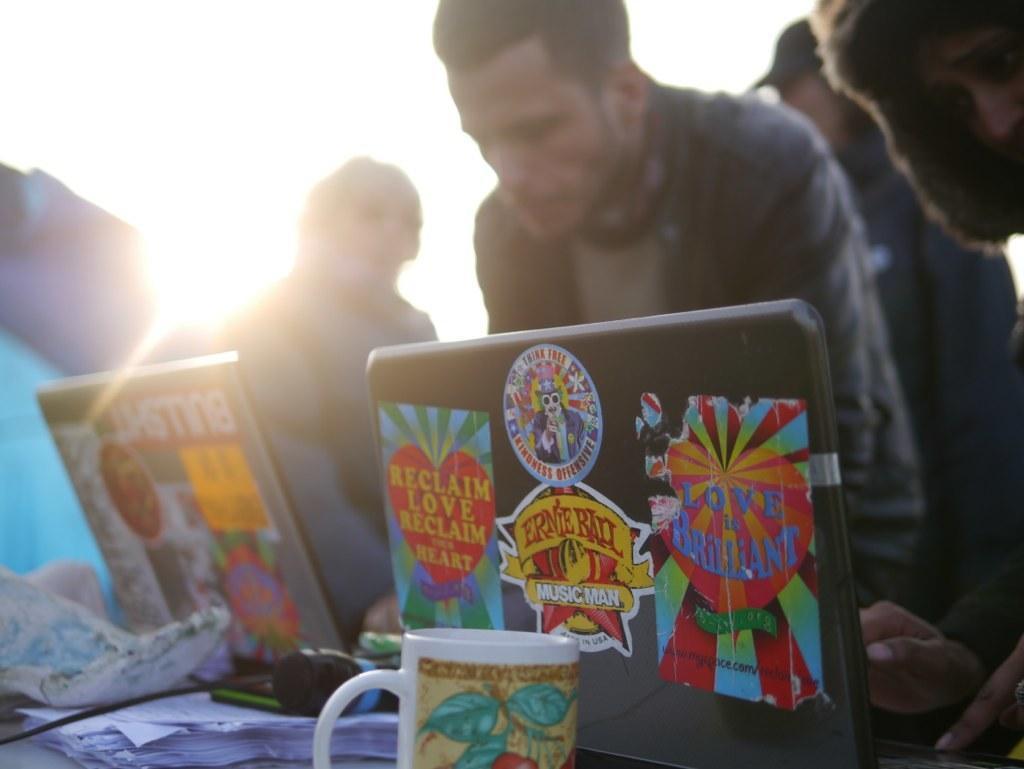Describe this image in one or two sentences. In the picture I can see laptops, papers and cup are placed on the table. The background of the image is slightly blurred, where I can see people are standing and I can see the sun here. 